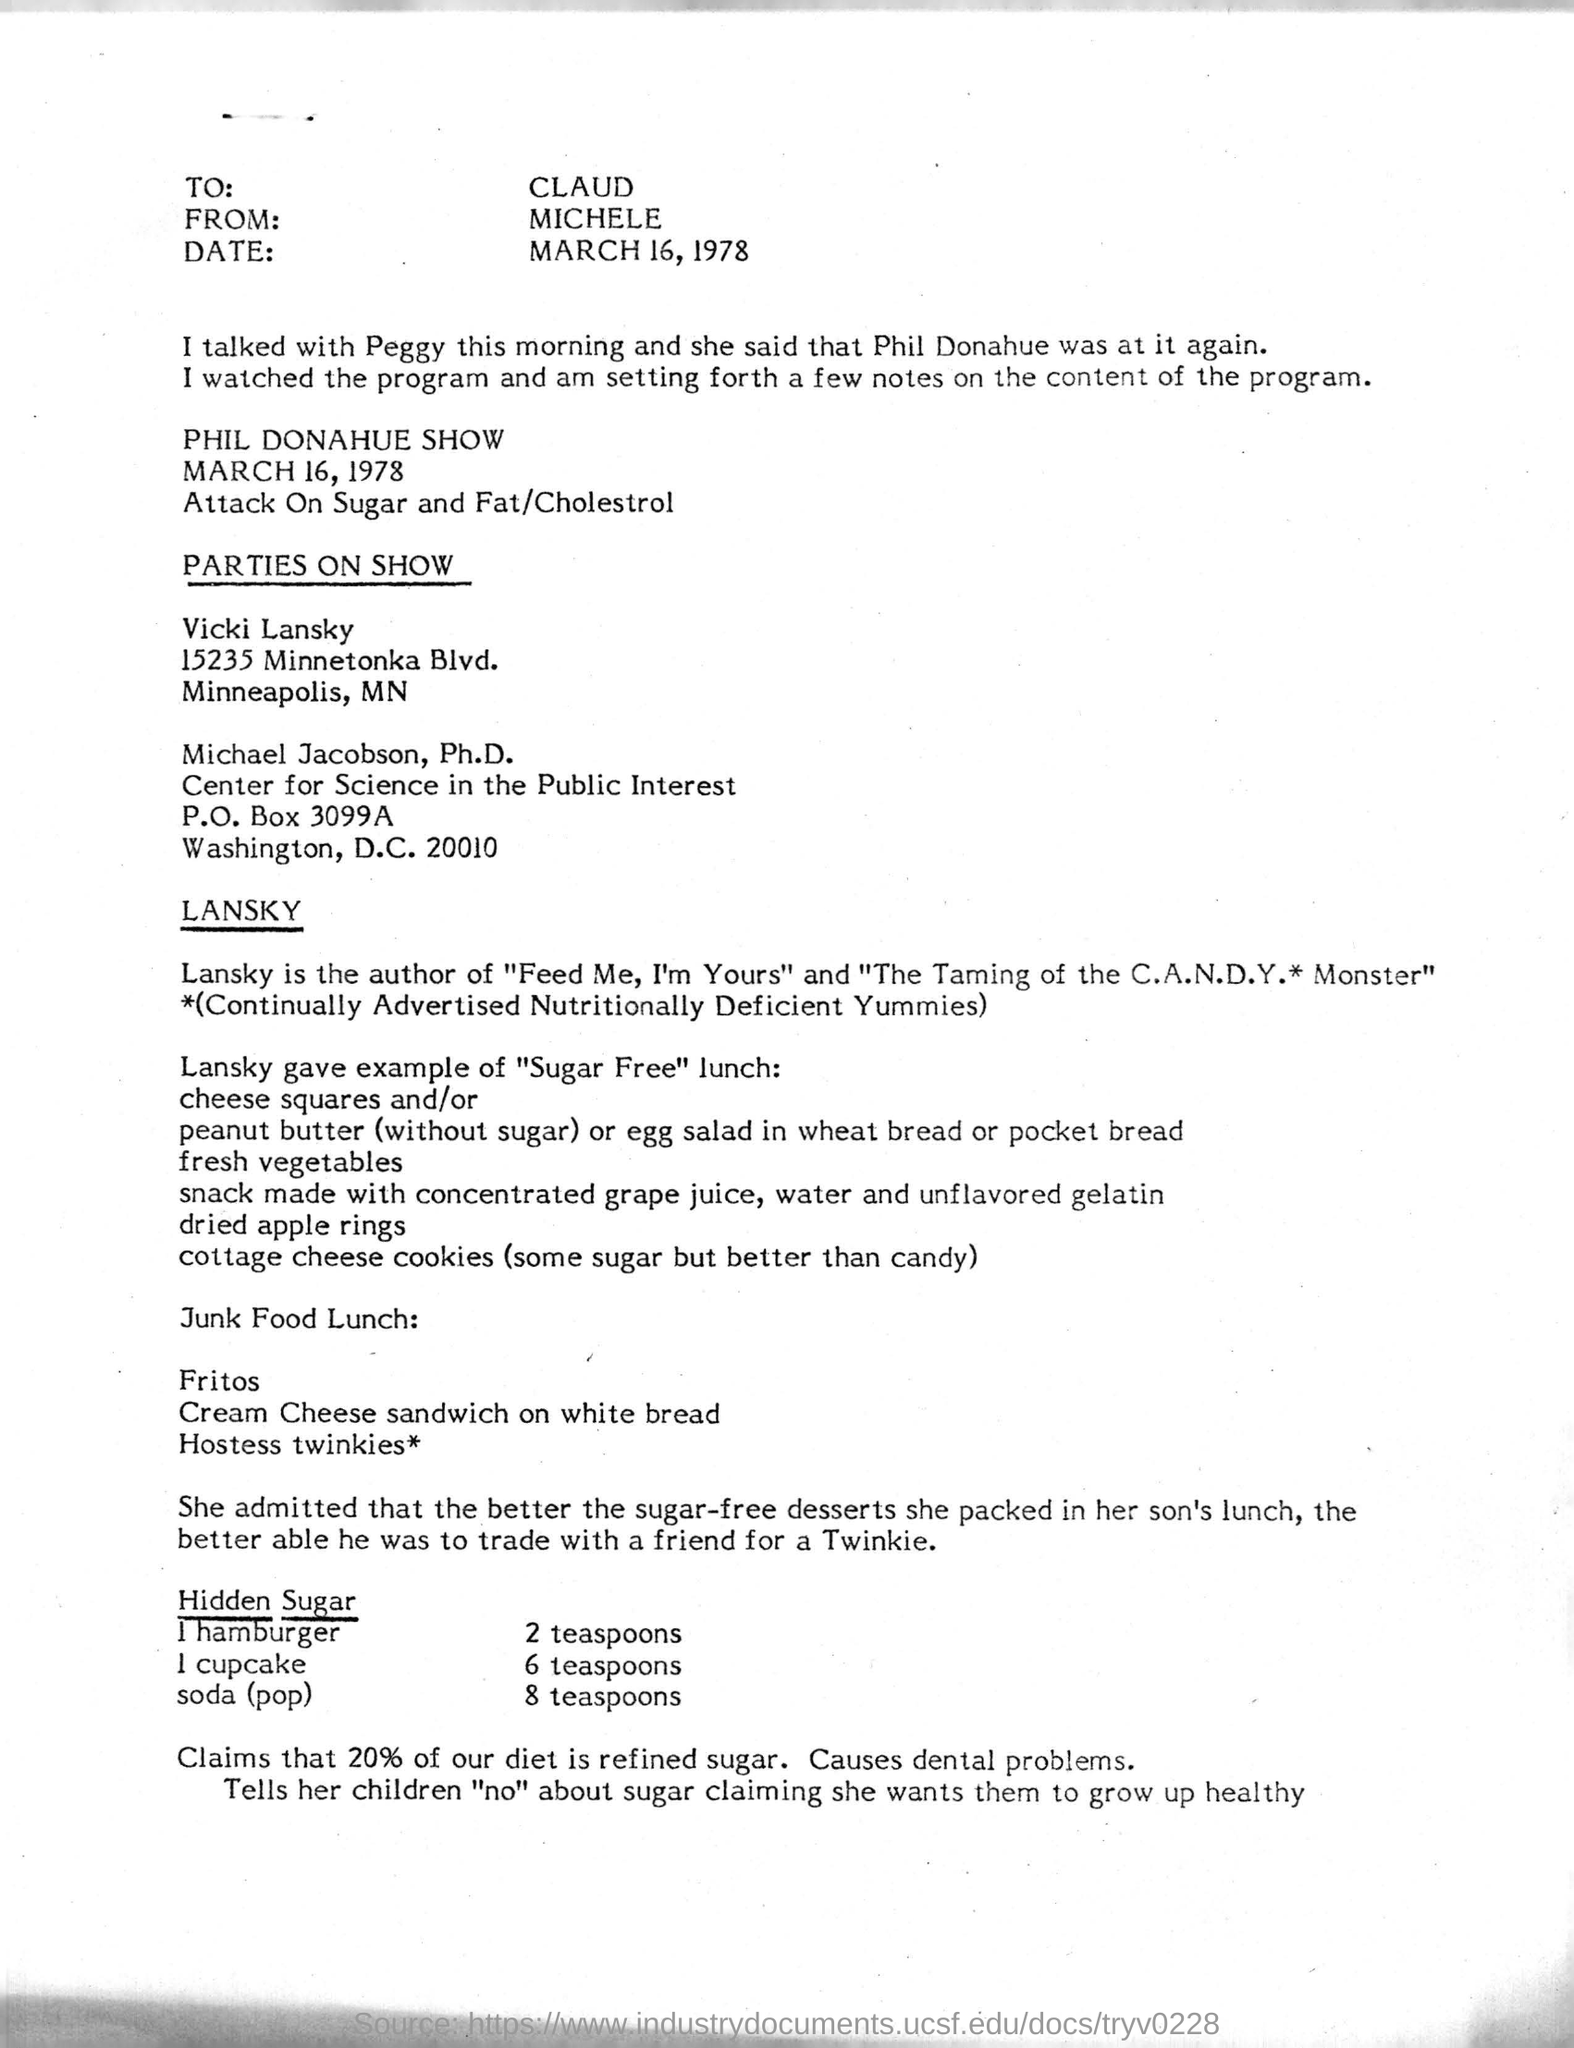Who is this letter from?
Your answer should be very brief. Michele. To Whom is this letter addressed to?
Ensure brevity in your answer.  CLAUD. Who is the author of " The Taming of the C.A.N.D.Y. Monster"?
Your answer should be very brief. LANSKY. 